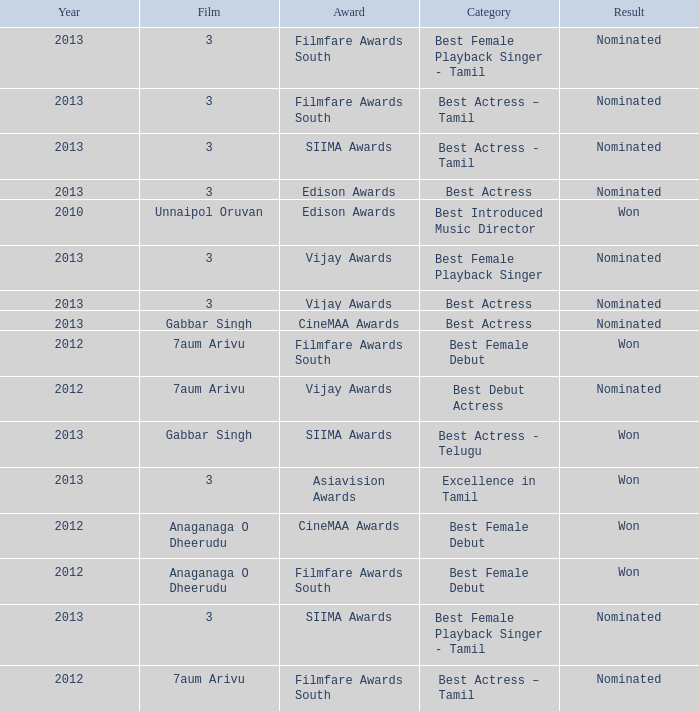What was the award for the excellence in tamil category? Asiavision Awards. 